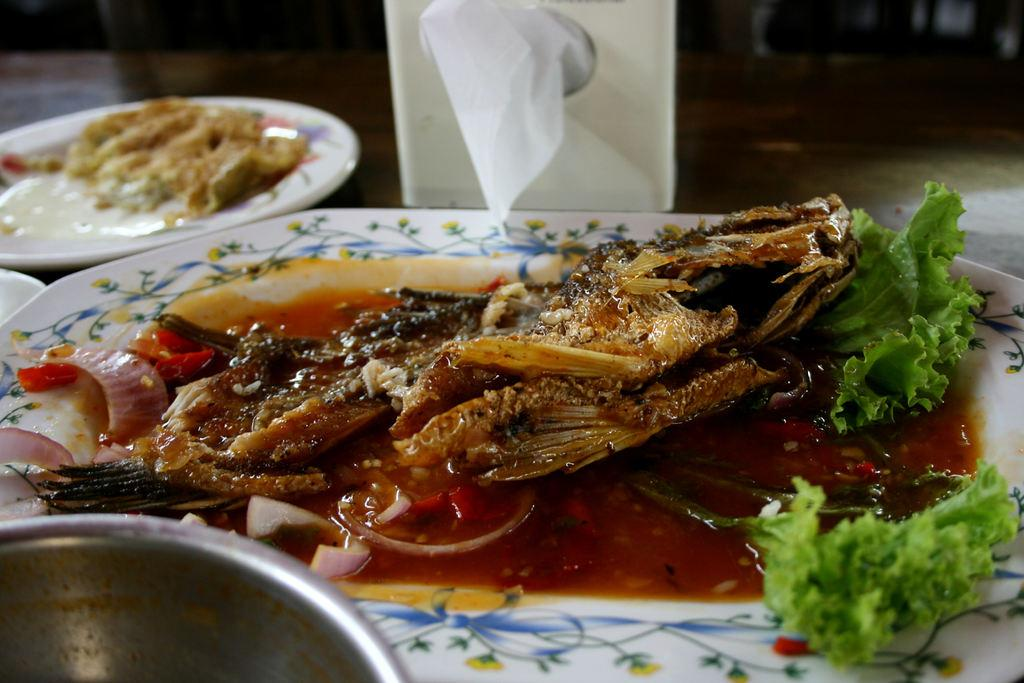What is present on the plate in the image? There are food items on the plate in the image. How deep is the ocean in the image? There is no ocean present in the image; it features a plate with food items. What type of scarf is draped over the food in the image? There is no scarf present in the image; it features a plate with food items. 